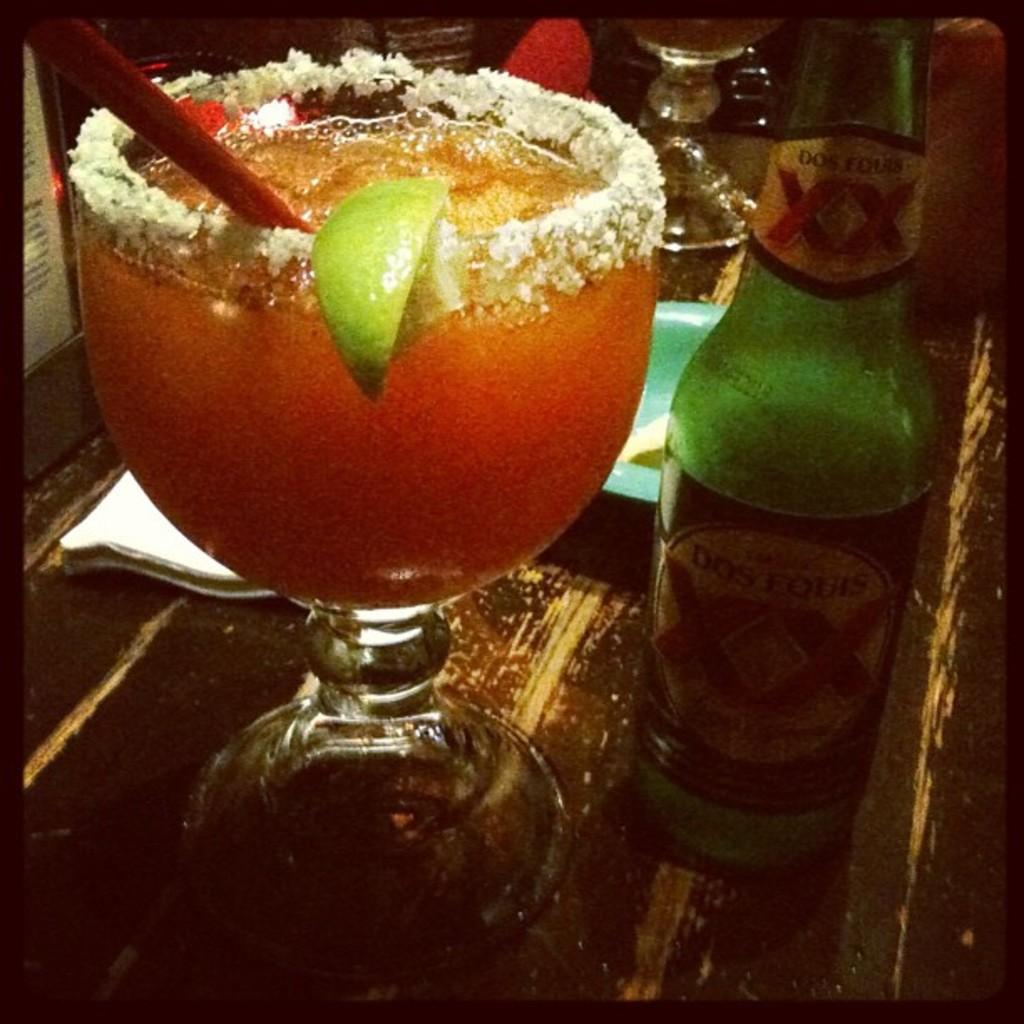<image>
Present a compact description of the photo's key features. A bottle of Dos Equis sits on a table next to a cocktail. 